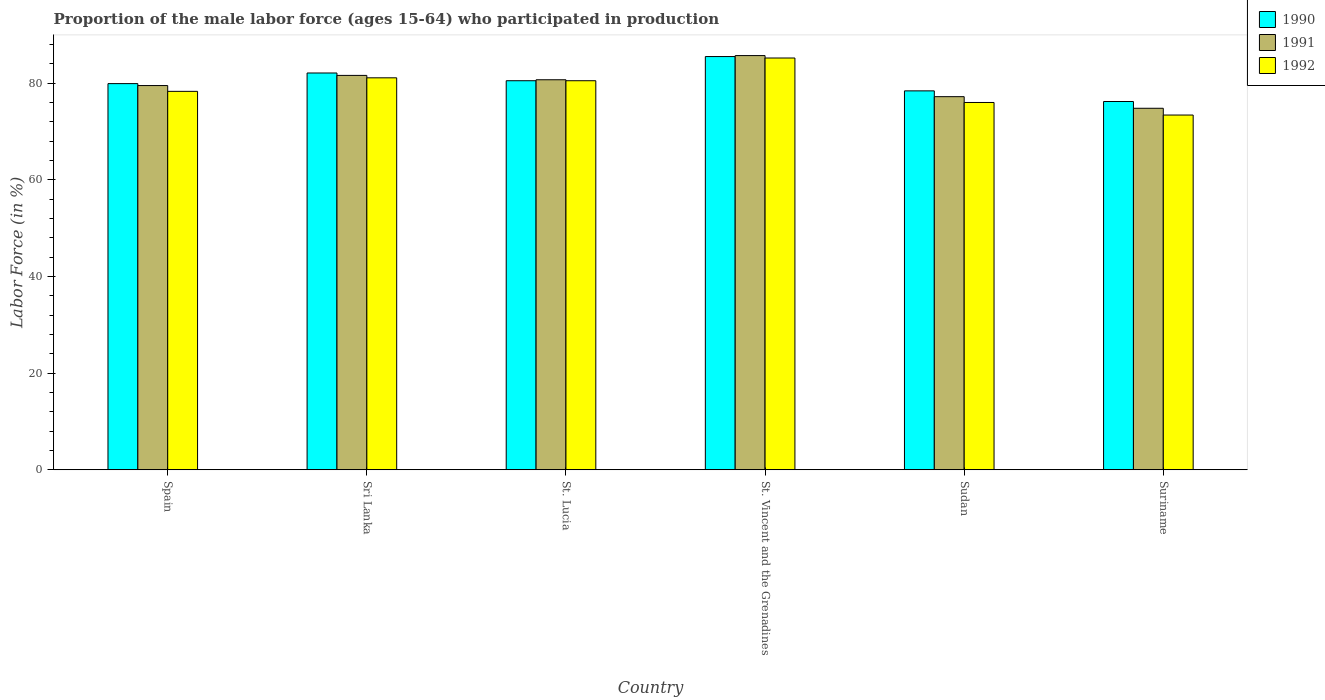How many groups of bars are there?
Give a very brief answer. 6. How many bars are there on the 1st tick from the left?
Ensure brevity in your answer.  3. What is the label of the 3rd group of bars from the left?
Give a very brief answer. St. Lucia. In how many cases, is the number of bars for a given country not equal to the number of legend labels?
Offer a terse response. 0. What is the proportion of the male labor force who participated in production in 1992 in Sri Lanka?
Offer a very short reply. 81.1. Across all countries, what is the maximum proportion of the male labor force who participated in production in 1990?
Your answer should be very brief. 85.5. Across all countries, what is the minimum proportion of the male labor force who participated in production in 1991?
Your response must be concise. 74.8. In which country was the proportion of the male labor force who participated in production in 1992 maximum?
Provide a short and direct response. St. Vincent and the Grenadines. In which country was the proportion of the male labor force who participated in production in 1991 minimum?
Keep it short and to the point. Suriname. What is the total proportion of the male labor force who participated in production in 1991 in the graph?
Your response must be concise. 479.5. What is the difference between the proportion of the male labor force who participated in production in 1990 in Spain and that in St. Lucia?
Provide a succinct answer. -0.6. What is the difference between the proportion of the male labor force who participated in production in 1990 in Spain and the proportion of the male labor force who participated in production in 1991 in Suriname?
Your answer should be very brief. 5.1. What is the average proportion of the male labor force who participated in production in 1991 per country?
Keep it short and to the point. 79.92. In how many countries, is the proportion of the male labor force who participated in production in 1991 greater than 48 %?
Offer a terse response. 6. What is the ratio of the proportion of the male labor force who participated in production in 1992 in St. Lucia to that in St. Vincent and the Grenadines?
Your response must be concise. 0.94. What is the difference between the highest and the second highest proportion of the male labor force who participated in production in 1992?
Provide a succinct answer. -0.6. What is the difference between the highest and the lowest proportion of the male labor force who participated in production in 1991?
Offer a terse response. 10.9. What does the 2nd bar from the left in Spain represents?
Your response must be concise. 1991. What does the 2nd bar from the right in Sudan represents?
Give a very brief answer. 1991. Is it the case that in every country, the sum of the proportion of the male labor force who participated in production in 1991 and proportion of the male labor force who participated in production in 1992 is greater than the proportion of the male labor force who participated in production in 1990?
Provide a short and direct response. Yes. How many bars are there?
Keep it short and to the point. 18. Are all the bars in the graph horizontal?
Offer a terse response. No. What is the difference between two consecutive major ticks on the Y-axis?
Provide a succinct answer. 20. Are the values on the major ticks of Y-axis written in scientific E-notation?
Offer a terse response. No. Does the graph contain any zero values?
Ensure brevity in your answer.  No. Does the graph contain grids?
Provide a succinct answer. No. Where does the legend appear in the graph?
Provide a succinct answer. Top right. How are the legend labels stacked?
Make the answer very short. Vertical. What is the title of the graph?
Provide a short and direct response. Proportion of the male labor force (ages 15-64) who participated in production. Does "1961" appear as one of the legend labels in the graph?
Provide a succinct answer. No. What is the label or title of the X-axis?
Your answer should be compact. Country. What is the label or title of the Y-axis?
Make the answer very short. Labor Force (in %). What is the Labor Force (in %) in 1990 in Spain?
Offer a terse response. 79.9. What is the Labor Force (in %) of 1991 in Spain?
Keep it short and to the point. 79.5. What is the Labor Force (in %) of 1992 in Spain?
Your response must be concise. 78.3. What is the Labor Force (in %) of 1990 in Sri Lanka?
Your answer should be compact. 82.1. What is the Labor Force (in %) in 1991 in Sri Lanka?
Your response must be concise. 81.6. What is the Labor Force (in %) in 1992 in Sri Lanka?
Your answer should be very brief. 81.1. What is the Labor Force (in %) in 1990 in St. Lucia?
Your answer should be very brief. 80.5. What is the Labor Force (in %) in 1991 in St. Lucia?
Your response must be concise. 80.7. What is the Labor Force (in %) of 1992 in St. Lucia?
Ensure brevity in your answer.  80.5. What is the Labor Force (in %) in 1990 in St. Vincent and the Grenadines?
Provide a succinct answer. 85.5. What is the Labor Force (in %) of 1991 in St. Vincent and the Grenadines?
Offer a terse response. 85.7. What is the Labor Force (in %) in 1992 in St. Vincent and the Grenadines?
Ensure brevity in your answer.  85.2. What is the Labor Force (in %) of 1990 in Sudan?
Keep it short and to the point. 78.4. What is the Labor Force (in %) in 1991 in Sudan?
Offer a very short reply. 77.2. What is the Labor Force (in %) in 1992 in Sudan?
Ensure brevity in your answer.  76. What is the Labor Force (in %) of 1990 in Suriname?
Provide a succinct answer. 76.2. What is the Labor Force (in %) in 1991 in Suriname?
Your answer should be very brief. 74.8. What is the Labor Force (in %) of 1992 in Suriname?
Ensure brevity in your answer.  73.4. Across all countries, what is the maximum Labor Force (in %) of 1990?
Your answer should be very brief. 85.5. Across all countries, what is the maximum Labor Force (in %) in 1991?
Your response must be concise. 85.7. Across all countries, what is the maximum Labor Force (in %) of 1992?
Give a very brief answer. 85.2. Across all countries, what is the minimum Labor Force (in %) in 1990?
Keep it short and to the point. 76.2. Across all countries, what is the minimum Labor Force (in %) of 1991?
Your response must be concise. 74.8. Across all countries, what is the minimum Labor Force (in %) in 1992?
Your answer should be very brief. 73.4. What is the total Labor Force (in %) in 1990 in the graph?
Make the answer very short. 482.6. What is the total Labor Force (in %) in 1991 in the graph?
Your answer should be compact. 479.5. What is the total Labor Force (in %) in 1992 in the graph?
Keep it short and to the point. 474.5. What is the difference between the Labor Force (in %) in 1991 in Spain and that in Sri Lanka?
Provide a succinct answer. -2.1. What is the difference between the Labor Force (in %) in 1992 in Spain and that in Sri Lanka?
Ensure brevity in your answer.  -2.8. What is the difference between the Labor Force (in %) in 1991 in Spain and that in St. Lucia?
Give a very brief answer. -1.2. What is the difference between the Labor Force (in %) of 1992 in Spain and that in St. Lucia?
Your answer should be compact. -2.2. What is the difference between the Labor Force (in %) of 1990 in Spain and that in St. Vincent and the Grenadines?
Offer a very short reply. -5.6. What is the difference between the Labor Force (in %) in 1991 in Spain and that in St. Vincent and the Grenadines?
Offer a very short reply. -6.2. What is the difference between the Labor Force (in %) of 1990 in Spain and that in Sudan?
Provide a short and direct response. 1.5. What is the difference between the Labor Force (in %) of 1991 in Spain and that in Suriname?
Offer a terse response. 4.7. What is the difference between the Labor Force (in %) of 1991 in Sri Lanka and that in St. Lucia?
Offer a very short reply. 0.9. What is the difference between the Labor Force (in %) in 1991 in Sri Lanka and that in Sudan?
Offer a very short reply. 4.4. What is the difference between the Labor Force (in %) in 1992 in Sri Lanka and that in Sudan?
Offer a terse response. 5.1. What is the difference between the Labor Force (in %) of 1990 in Sri Lanka and that in Suriname?
Keep it short and to the point. 5.9. What is the difference between the Labor Force (in %) in 1990 in St. Lucia and that in St. Vincent and the Grenadines?
Offer a very short reply. -5. What is the difference between the Labor Force (in %) of 1992 in St. Lucia and that in St. Vincent and the Grenadines?
Your response must be concise. -4.7. What is the difference between the Labor Force (in %) of 1990 in St. Vincent and the Grenadines and that in Sudan?
Keep it short and to the point. 7.1. What is the difference between the Labor Force (in %) in 1991 in St. Vincent and the Grenadines and that in Sudan?
Provide a short and direct response. 8.5. What is the difference between the Labor Force (in %) of 1992 in St. Vincent and the Grenadines and that in Sudan?
Provide a short and direct response. 9.2. What is the difference between the Labor Force (in %) in 1990 in St. Vincent and the Grenadines and that in Suriname?
Make the answer very short. 9.3. What is the difference between the Labor Force (in %) in 1991 in St. Vincent and the Grenadines and that in Suriname?
Make the answer very short. 10.9. What is the difference between the Labor Force (in %) in 1990 in Sudan and that in Suriname?
Your response must be concise. 2.2. What is the difference between the Labor Force (in %) in 1991 in Spain and the Labor Force (in %) in 1992 in Sri Lanka?
Provide a short and direct response. -1.6. What is the difference between the Labor Force (in %) of 1990 in Spain and the Labor Force (in %) of 1991 in St. Lucia?
Your response must be concise. -0.8. What is the difference between the Labor Force (in %) in 1991 in Spain and the Labor Force (in %) in 1992 in St. Lucia?
Provide a succinct answer. -1. What is the difference between the Labor Force (in %) of 1990 in Spain and the Labor Force (in %) of 1992 in St. Vincent and the Grenadines?
Your answer should be very brief. -5.3. What is the difference between the Labor Force (in %) of 1990 in Spain and the Labor Force (in %) of 1991 in Sudan?
Provide a succinct answer. 2.7. What is the difference between the Labor Force (in %) in 1990 in Spain and the Labor Force (in %) in 1992 in Sudan?
Provide a short and direct response. 3.9. What is the difference between the Labor Force (in %) in 1991 in Spain and the Labor Force (in %) in 1992 in Sudan?
Ensure brevity in your answer.  3.5. What is the difference between the Labor Force (in %) in 1990 in Spain and the Labor Force (in %) in 1992 in Suriname?
Ensure brevity in your answer.  6.5. What is the difference between the Labor Force (in %) of 1991 in Spain and the Labor Force (in %) of 1992 in Suriname?
Your answer should be very brief. 6.1. What is the difference between the Labor Force (in %) of 1990 in Sri Lanka and the Labor Force (in %) of 1991 in St. Lucia?
Give a very brief answer. 1.4. What is the difference between the Labor Force (in %) in 1990 in Sri Lanka and the Labor Force (in %) in 1992 in St. Lucia?
Offer a very short reply. 1.6. What is the difference between the Labor Force (in %) in 1991 in Sri Lanka and the Labor Force (in %) in 1992 in St. Lucia?
Give a very brief answer. 1.1. What is the difference between the Labor Force (in %) of 1990 in Sri Lanka and the Labor Force (in %) of 1991 in St. Vincent and the Grenadines?
Give a very brief answer. -3.6. What is the difference between the Labor Force (in %) in 1991 in Sri Lanka and the Labor Force (in %) in 1992 in St. Vincent and the Grenadines?
Provide a short and direct response. -3.6. What is the difference between the Labor Force (in %) in 1990 in Sri Lanka and the Labor Force (in %) in 1991 in Sudan?
Offer a terse response. 4.9. What is the difference between the Labor Force (in %) of 1990 in Sri Lanka and the Labor Force (in %) of 1991 in Suriname?
Provide a succinct answer. 7.3. What is the difference between the Labor Force (in %) of 1991 in St. Lucia and the Labor Force (in %) of 1992 in St. Vincent and the Grenadines?
Offer a very short reply. -4.5. What is the difference between the Labor Force (in %) of 1990 in St. Lucia and the Labor Force (in %) of 1991 in Sudan?
Give a very brief answer. 3.3. What is the difference between the Labor Force (in %) of 1990 in St. Lucia and the Labor Force (in %) of 1992 in Sudan?
Offer a terse response. 4.5. What is the difference between the Labor Force (in %) of 1991 in St. Lucia and the Labor Force (in %) of 1992 in Suriname?
Ensure brevity in your answer.  7.3. What is the difference between the Labor Force (in %) of 1990 in St. Vincent and the Grenadines and the Labor Force (in %) of 1991 in Suriname?
Make the answer very short. 10.7. What is the difference between the Labor Force (in %) in 1990 in St. Vincent and the Grenadines and the Labor Force (in %) in 1992 in Suriname?
Make the answer very short. 12.1. What is the difference between the Labor Force (in %) of 1991 in St. Vincent and the Grenadines and the Labor Force (in %) of 1992 in Suriname?
Offer a terse response. 12.3. What is the difference between the Labor Force (in %) of 1990 in Sudan and the Labor Force (in %) of 1992 in Suriname?
Your response must be concise. 5. What is the average Labor Force (in %) of 1990 per country?
Your answer should be very brief. 80.43. What is the average Labor Force (in %) of 1991 per country?
Your answer should be very brief. 79.92. What is the average Labor Force (in %) of 1992 per country?
Offer a terse response. 79.08. What is the difference between the Labor Force (in %) in 1991 and Labor Force (in %) in 1992 in Spain?
Give a very brief answer. 1.2. What is the difference between the Labor Force (in %) in 1991 and Labor Force (in %) in 1992 in Sri Lanka?
Your answer should be very brief. 0.5. What is the difference between the Labor Force (in %) of 1991 and Labor Force (in %) of 1992 in St. Lucia?
Offer a terse response. 0.2. What is the difference between the Labor Force (in %) of 1990 and Labor Force (in %) of 1991 in St. Vincent and the Grenadines?
Ensure brevity in your answer.  -0.2. What is the difference between the Labor Force (in %) of 1990 and Labor Force (in %) of 1992 in St. Vincent and the Grenadines?
Your response must be concise. 0.3. What is the difference between the Labor Force (in %) in 1990 and Labor Force (in %) in 1991 in Sudan?
Give a very brief answer. 1.2. What is the difference between the Labor Force (in %) of 1990 and Labor Force (in %) of 1992 in Sudan?
Your answer should be very brief. 2.4. What is the difference between the Labor Force (in %) in 1991 and Labor Force (in %) in 1992 in Sudan?
Offer a very short reply. 1.2. What is the difference between the Labor Force (in %) of 1990 and Labor Force (in %) of 1992 in Suriname?
Your response must be concise. 2.8. What is the ratio of the Labor Force (in %) of 1990 in Spain to that in Sri Lanka?
Keep it short and to the point. 0.97. What is the ratio of the Labor Force (in %) of 1991 in Spain to that in Sri Lanka?
Keep it short and to the point. 0.97. What is the ratio of the Labor Force (in %) of 1992 in Spain to that in Sri Lanka?
Provide a short and direct response. 0.97. What is the ratio of the Labor Force (in %) of 1991 in Spain to that in St. Lucia?
Your response must be concise. 0.99. What is the ratio of the Labor Force (in %) of 1992 in Spain to that in St. Lucia?
Offer a terse response. 0.97. What is the ratio of the Labor Force (in %) in 1990 in Spain to that in St. Vincent and the Grenadines?
Make the answer very short. 0.93. What is the ratio of the Labor Force (in %) in 1991 in Spain to that in St. Vincent and the Grenadines?
Your response must be concise. 0.93. What is the ratio of the Labor Force (in %) in 1992 in Spain to that in St. Vincent and the Grenadines?
Offer a very short reply. 0.92. What is the ratio of the Labor Force (in %) of 1990 in Spain to that in Sudan?
Provide a succinct answer. 1.02. What is the ratio of the Labor Force (in %) of 1991 in Spain to that in Sudan?
Provide a short and direct response. 1.03. What is the ratio of the Labor Force (in %) of 1992 in Spain to that in Sudan?
Ensure brevity in your answer.  1.03. What is the ratio of the Labor Force (in %) in 1990 in Spain to that in Suriname?
Keep it short and to the point. 1.05. What is the ratio of the Labor Force (in %) in 1991 in Spain to that in Suriname?
Make the answer very short. 1.06. What is the ratio of the Labor Force (in %) of 1992 in Spain to that in Suriname?
Provide a short and direct response. 1.07. What is the ratio of the Labor Force (in %) of 1990 in Sri Lanka to that in St. Lucia?
Provide a short and direct response. 1.02. What is the ratio of the Labor Force (in %) in 1991 in Sri Lanka to that in St. Lucia?
Make the answer very short. 1.01. What is the ratio of the Labor Force (in %) in 1992 in Sri Lanka to that in St. Lucia?
Offer a very short reply. 1.01. What is the ratio of the Labor Force (in %) in 1990 in Sri Lanka to that in St. Vincent and the Grenadines?
Make the answer very short. 0.96. What is the ratio of the Labor Force (in %) in 1991 in Sri Lanka to that in St. Vincent and the Grenadines?
Provide a short and direct response. 0.95. What is the ratio of the Labor Force (in %) in 1992 in Sri Lanka to that in St. Vincent and the Grenadines?
Make the answer very short. 0.95. What is the ratio of the Labor Force (in %) of 1990 in Sri Lanka to that in Sudan?
Keep it short and to the point. 1.05. What is the ratio of the Labor Force (in %) in 1991 in Sri Lanka to that in Sudan?
Offer a very short reply. 1.06. What is the ratio of the Labor Force (in %) in 1992 in Sri Lanka to that in Sudan?
Your response must be concise. 1.07. What is the ratio of the Labor Force (in %) of 1990 in Sri Lanka to that in Suriname?
Offer a very short reply. 1.08. What is the ratio of the Labor Force (in %) in 1992 in Sri Lanka to that in Suriname?
Your response must be concise. 1.1. What is the ratio of the Labor Force (in %) of 1990 in St. Lucia to that in St. Vincent and the Grenadines?
Offer a very short reply. 0.94. What is the ratio of the Labor Force (in %) of 1991 in St. Lucia to that in St. Vincent and the Grenadines?
Provide a short and direct response. 0.94. What is the ratio of the Labor Force (in %) in 1992 in St. Lucia to that in St. Vincent and the Grenadines?
Provide a short and direct response. 0.94. What is the ratio of the Labor Force (in %) of 1990 in St. Lucia to that in Sudan?
Make the answer very short. 1.03. What is the ratio of the Labor Force (in %) in 1991 in St. Lucia to that in Sudan?
Ensure brevity in your answer.  1.05. What is the ratio of the Labor Force (in %) of 1992 in St. Lucia to that in Sudan?
Your answer should be compact. 1.06. What is the ratio of the Labor Force (in %) of 1990 in St. Lucia to that in Suriname?
Provide a short and direct response. 1.06. What is the ratio of the Labor Force (in %) in 1991 in St. Lucia to that in Suriname?
Your answer should be compact. 1.08. What is the ratio of the Labor Force (in %) of 1992 in St. Lucia to that in Suriname?
Make the answer very short. 1.1. What is the ratio of the Labor Force (in %) of 1990 in St. Vincent and the Grenadines to that in Sudan?
Ensure brevity in your answer.  1.09. What is the ratio of the Labor Force (in %) in 1991 in St. Vincent and the Grenadines to that in Sudan?
Offer a very short reply. 1.11. What is the ratio of the Labor Force (in %) in 1992 in St. Vincent and the Grenadines to that in Sudan?
Offer a terse response. 1.12. What is the ratio of the Labor Force (in %) of 1990 in St. Vincent and the Grenadines to that in Suriname?
Offer a terse response. 1.12. What is the ratio of the Labor Force (in %) in 1991 in St. Vincent and the Grenadines to that in Suriname?
Your answer should be very brief. 1.15. What is the ratio of the Labor Force (in %) of 1992 in St. Vincent and the Grenadines to that in Suriname?
Ensure brevity in your answer.  1.16. What is the ratio of the Labor Force (in %) in 1990 in Sudan to that in Suriname?
Ensure brevity in your answer.  1.03. What is the ratio of the Labor Force (in %) in 1991 in Sudan to that in Suriname?
Offer a terse response. 1.03. What is the ratio of the Labor Force (in %) in 1992 in Sudan to that in Suriname?
Provide a succinct answer. 1.04. What is the difference between the highest and the second highest Labor Force (in %) in 1990?
Ensure brevity in your answer.  3.4. What is the difference between the highest and the second highest Labor Force (in %) of 1991?
Provide a short and direct response. 4.1. What is the difference between the highest and the second highest Labor Force (in %) in 1992?
Provide a succinct answer. 4.1. What is the difference between the highest and the lowest Labor Force (in %) of 1991?
Offer a terse response. 10.9. 